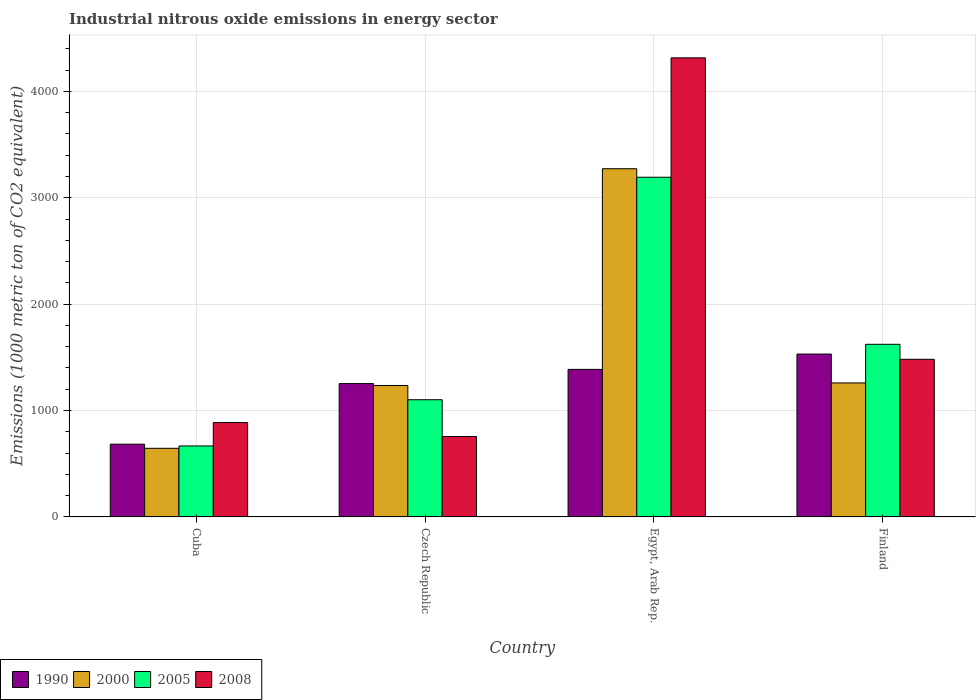How many different coloured bars are there?
Offer a very short reply. 4. Are the number of bars per tick equal to the number of legend labels?
Keep it short and to the point. Yes. Are the number of bars on each tick of the X-axis equal?
Keep it short and to the point. Yes. How many bars are there on the 2nd tick from the right?
Offer a very short reply. 4. What is the label of the 4th group of bars from the left?
Provide a succinct answer. Finland. What is the amount of industrial nitrous oxide emitted in 1990 in Cuba?
Make the answer very short. 683.6. Across all countries, what is the maximum amount of industrial nitrous oxide emitted in 2000?
Your response must be concise. 3272.7. Across all countries, what is the minimum amount of industrial nitrous oxide emitted in 1990?
Your answer should be compact. 683.6. In which country was the amount of industrial nitrous oxide emitted in 2008 maximum?
Keep it short and to the point. Egypt, Arab Rep. In which country was the amount of industrial nitrous oxide emitted in 2008 minimum?
Offer a very short reply. Czech Republic. What is the total amount of industrial nitrous oxide emitted in 2005 in the graph?
Your response must be concise. 6583.6. What is the difference between the amount of industrial nitrous oxide emitted in 2005 in Cuba and that in Egypt, Arab Rep.?
Your answer should be very brief. -2525.5. What is the difference between the amount of industrial nitrous oxide emitted in 2000 in Egypt, Arab Rep. and the amount of industrial nitrous oxide emitted in 2008 in Finland?
Make the answer very short. 1791.2. What is the average amount of industrial nitrous oxide emitted in 1990 per country?
Give a very brief answer. 1213.6. What is the difference between the amount of industrial nitrous oxide emitted of/in 2000 and amount of industrial nitrous oxide emitted of/in 2008 in Egypt, Arab Rep.?
Provide a succinct answer. -1042.3. What is the ratio of the amount of industrial nitrous oxide emitted in 2000 in Cuba to that in Finland?
Provide a short and direct response. 0.51. Is the amount of industrial nitrous oxide emitted in 1990 in Cuba less than that in Finland?
Your answer should be compact. Yes. What is the difference between the highest and the second highest amount of industrial nitrous oxide emitted in 2008?
Offer a very short reply. -2833.5. What is the difference between the highest and the lowest amount of industrial nitrous oxide emitted in 1990?
Offer a terse response. 847.3. In how many countries, is the amount of industrial nitrous oxide emitted in 2008 greater than the average amount of industrial nitrous oxide emitted in 2008 taken over all countries?
Offer a terse response. 1. Is the sum of the amount of industrial nitrous oxide emitted in 2008 in Czech Republic and Finland greater than the maximum amount of industrial nitrous oxide emitted in 1990 across all countries?
Provide a succinct answer. Yes. What does the 4th bar from the right in Finland represents?
Provide a short and direct response. 1990. Is it the case that in every country, the sum of the amount of industrial nitrous oxide emitted in 1990 and amount of industrial nitrous oxide emitted in 2000 is greater than the amount of industrial nitrous oxide emitted in 2008?
Ensure brevity in your answer.  Yes. What is the difference between two consecutive major ticks on the Y-axis?
Your answer should be very brief. 1000. Where does the legend appear in the graph?
Your response must be concise. Bottom left. How many legend labels are there?
Provide a short and direct response. 4. What is the title of the graph?
Ensure brevity in your answer.  Industrial nitrous oxide emissions in energy sector. What is the label or title of the X-axis?
Make the answer very short. Country. What is the label or title of the Y-axis?
Ensure brevity in your answer.  Emissions (1000 metric ton of CO2 equivalent). What is the Emissions (1000 metric ton of CO2 equivalent) of 1990 in Cuba?
Make the answer very short. 683.6. What is the Emissions (1000 metric ton of CO2 equivalent) of 2000 in Cuba?
Provide a succinct answer. 645. What is the Emissions (1000 metric ton of CO2 equivalent) of 2005 in Cuba?
Make the answer very short. 667.1. What is the Emissions (1000 metric ton of CO2 equivalent) of 2008 in Cuba?
Your response must be concise. 886.9. What is the Emissions (1000 metric ton of CO2 equivalent) in 1990 in Czech Republic?
Offer a very short reply. 1253.3. What is the Emissions (1000 metric ton of CO2 equivalent) in 2000 in Czech Republic?
Keep it short and to the point. 1235.4. What is the Emissions (1000 metric ton of CO2 equivalent) in 2005 in Czech Republic?
Ensure brevity in your answer.  1101.5. What is the Emissions (1000 metric ton of CO2 equivalent) of 2008 in Czech Republic?
Give a very brief answer. 756. What is the Emissions (1000 metric ton of CO2 equivalent) in 1990 in Egypt, Arab Rep.?
Offer a terse response. 1386.6. What is the Emissions (1000 metric ton of CO2 equivalent) in 2000 in Egypt, Arab Rep.?
Offer a very short reply. 3272.7. What is the Emissions (1000 metric ton of CO2 equivalent) in 2005 in Egypt, Arab Rep.?
Keep it short and to the point. 3192.6. What is the Emissions (1000 metric ton of CO2 equivalent) of 2008 in Egypt, Arab Rep.?
Ensure brevity in your answer.  4315. What is the Emissions (1000 metric ton of CO2 equivalent) of 1990 in Finland?
Your answer should be very brief. 1530.9. What is the Emissions (1000 metric ton of CO2 equivalent) of 2000 in Finland?
Provide a short and direct response. 1259.4. What is the Emissions (1000 metric ton of CO2 equivalent) of 2005 in Finland?
Provide a succinct answer. 1622.4. What is the Emissions (1000 metric ton of CO2 equivalent) in 2008 in Finland?
Provide a succinct answer. 1481.5. Across all countries, what is the maximum Emissions (1000 metric ton of CO2 equivalent) of 1990?
Your answer should be very brief. 1530.9. Across all countries, what is the maximum Emissions (1000 metric ton of CO2 equivalent) in 2000?
Give a very brief answer. 3272.7. Across all countries, what is the maximum Emissions (1000 metric ton of CO2 equivalent) in 2005?
Your answer should be very brief. 3192.6. Across all countries, what is the maximum Emissions (1000 metric ton of CO2 equivalent) in 2008?
Give a very brief answer. 4315. Across all countries, what is the minimum Emissions (1000 metric ton of CO2 equivalent) in 1990?
Provide a succinct answer. 683.6. Across all countries, what is the minimum Emissions (1000 metric ton of CO2 equivalent) in 2000?
Your answer should be very brief. 645. Across all countries, what is the minimum Emissions (1000 metric ton of CO2 equivalent) in 2005?
Your response must be concise. 667.1. Across all countries, what is the minimum Emissions (1000 metric ton of CO2 equivalent) of 2008?
Offer a terse response. 756. What is the total Emissions (1000 metric ton of CO2 equivalent) of 1990 in the graph?
Offer a very short reply. 4854.4. What is the total Emissions (1000 metric ton of CO2 equivalent) of 2000 in the graph?
Provide a succinct answer. 6412.5. What is the total Emissions (1000 metric ton of CO2 equivalent) in 2005 in the graph?
Give a very brief answer. 6583.6. What is the total Emissions (1000 metric ton of CO2 equivalent) of 2008 in the graph?
Your response must be concise. 7439.4. What is the difference between the Emissions (1000 metric ton of CO2 equivalent) of 1990 in Cuba and that in Czech Republic?
Give a very brief answer. -569.7. What is the difference between the Emissions (1000 metric ton of CO2 equivalent) of 2000 in Cuba and that in Czech Republic?
Ensure brevity in your answer.  -590.4. What is the difference between the Emissions (1000 metric ton of CO2 equivalent) in 2005 in Cuba and that in Czech Republic?
Your answer should be compact. -434.4. What is the difference between the Emissions (1000 metric ton of CO2 equivalent) of 2008 in Cuba and that in Czech Republic?
Give a very brief answer. 130.9. What is the difference between the Emissions (1000 metric ton of CO2 equivalent) of 1990 in Cuba and that in Egypt, Arab Rep.?
Make the answer very short. -703. What is the difference between the Emissions (1000 metric ton of CO2 equivalent) of 2000 in Cuba and that in Egypt, Arab Rep.?
Your response must be concise. -2627.7. What is the difference between the Emissions (1000 metric ton of CO2 equivalent) in 2005 in Cuba and that in Egypt, Arab Rep.?
Make the answer very short. -2525.5. What is the difference between the Emissions (1000 metric ton of CO2 equivalent) in 2008 in Cuba and that in Egypt, Arab Rep.?
Make the answer very short. -3428.1. What is the difference between the Emissions (1000 metric ton of CO2 equivalent) of 1990 in Cuba and that in Finland?
Ensure brevity in your answer.  -847.3. What is the difference between the Emissions (1000 metric ton of CO2 equivalent) of 2000 in Cuba and that in Finland?
Ensure brevity in your answer.  -614.4. What is the difference between the Emissions (1000 metric ton of CO2 equivalent) in 2005 in Cuba and that in Finland?
Make the answer very short. -955.3. What is the difference between the Emissions (1000 metric ton of CO2 equivalent) in 2008 in Cuba and that in Finland?
Your answer should be compact. -594.6. What is the difference between the Emissions (1000 metric ton of CO2 equivalent) of 1990 in Czech Republic and that in Egypt, Arab Rep.?
Offer a terse response. -133.3. What is the difference between the Emissions (1000 metric ton of CO2 equivalent) of 2000 in Czech Republic and that in Egypt, Arab Rep.?
Offer a terse response. -2037.3. What is the difference between the Emissions (1000 metric ton of CO2 equivalent) in 2005 in Czech Republic and that in Egypt, Arab Rep.?
Your answer should be compact. -2091.1. What is the difference between the Emissions (1000 metric ton of CO2 equivalent) of 2008 in Czech Republic and that in Egypt, Arab Rep.?
Offer a terse response. -3559. What is the difference between the Emissions (1000 metric ton of CO2 equivalent) of 1990 in Czech Republic and that in Finland?
Offer a very short reply. -277.6. What is the difference between the Emissions (1000 metric ton of CO2 equivalent) of 2005 in Czech Republic and that in Finland?
Ensure brevity in your answer.  -520.9. What is the difference between the Emissions (1000 metric ton of CO2 equivalent) in 2008 in Czech Republic and that in Finland?
Make the answer very short. -725.5. What is the difference between the Emissions (1000 metric ton of CO2 equivalent) in 1990 in Egypt, Arab Rep. and that in Finland?
Give a very brief answer. -144.3. What is the difference between the Emissions (1000 metric ton of CO2 equivalent) in 2000 in Egypt, Arab Rep. and that in Finland?
Ensure brevity in your answer.  2013.3. What is the difference between the Emissions (1000 metric ton of CO2 equivalent) in 2005 in Egypt, Arab Rep. and that in Finland?
Offer a terse response. 1570.2. What is the difference between the Emissions (1000 metric ton of CO2 equivalent) in 2008 in Egypt, Arab Rep. and that in Finland?
Make the answer very short. 2833.5. What is the difference between the Emissions (1000 metric ton of CO2 equivalent) in 1990 in Cuba and the Emissions (1000 metric ton of CO2 equivalent) in 2000 in Czech Republic?
Keep it short and to the point. -551.8. What is the difference between the Emissions (1000 metric ton of CO2 equivalent) of 1990 in Cuba and the Emissions (1000 metric ton of CO2 equivalent) of 2005 in Czech Republic?
Offer a terse response. -417.9. What is the difference between the Emissions (1000 metric ton of CO2 equivalent) in 1990 in Cuba and the Emissions (1000 metric ton of CO2 equivalent) in 2008 in Czech Republic?
Offer a very short reply. -72.4. What is the difference between the Emissions (1000 metric ton of CO2 equivalent) in 2000 in Cuba and the Emissions (1000 metric ton of CO2 equivalent) in 2005 in Czech Republic?
Your response must be concise. -456.5. What is the difference between the Emissions (1000 metric ton of CO2 equivalent) of 2000 in Cuba and the Emissions (1000 metric ton of CO2 equivalent) of 2008 in Czech Republic?
Make the answer very short. -111. What is the difference between the Emissions (1000 metric ton of CO2 equivalent) in 2005 in Cuba and the Emissions (1000 metric ton of CO2 equivalent) in 2008 in Czech Republic?
Give a very brief answer. -88.9. What is the difference between the Emissions (1000 metric ton of CO2 equivalent) in 1990 in Cuba and the Emissions (1000 metric ton of CO2 equivalent) in 2000 in Egypt, Arab Rep.?
Provide a succinct answer. -2589.1. What is the difference between the Emissions (1000 metric ton of CO2 equivalent) of 1990 in Cuba and the Emissions (1000 metric ton of CO2 equivalent) of 2005 in Egypt, Arab Rep.?
Offer a terse response. -2509. What is the difference between the Emissions (1000 metric ton of CO2 equivalent) in 1990 in Cuba and the Emissions (1000 metric ton of CO2 equivalent) in 2008 in Egypt, Arab Rep.?
Provide a succinct answer. -3631.4. What is the difference between the Emissions (1000 metric ton of CO2 equivalent) of 2000 in Cuba and the Emissions (1000 metric ton of CO2 equivalent) of 2005 in Egypt, Arab Rep.?
Keep it short and to the point. -2547.6. What is the difference between the Emissions (1000 metric ton of CO2 equivalent) of 2000 in Cuba and the Emissions (1000 metric ton of CO2 equivalent) of 2008 in Egypt, Arab Rep.?
Offer a terse response. -3670. What is the difference between the Emissions (1000 metric ton of CO2 equivalent) of 2005 in Cuba and the Emissions (1000 metric ton of CO2 equivalent) of 2008 in Egypt, Arab Rep.?
Offer a very short reply. -3647.9. What is the difference between the Emissions (1000 metric ton of CO2 equivalent) of 1990 in Cuba and the Emissions (1000 metric ton of CO2 equivalent) of 2000 in Finland?
Provide a short and direct response. -575.8. What is the difference between the Emissions (1000 metric ton of CO2 equivalent) of 1990 in Cuba and the Emissions (1000 metric ton of CO2 equivalent) of 2005 in Finland?
Offer a terse response. -938.8. What is the difference between the Emissions (1000 metric ton of CO2 equivalent) in 1990 in Cuba and the Emissions (1000 metric ton of CO2 equivalent) in 2008 in Finland?
Your answer should be very brief. -797.9. What is the difference between the Emissions (1000 metric ton of CO2 equivalent) in 2000 in Cuba and the Emissions (1000 metric ton of CO2 equivalent) in 2005 in Finland?
Your answer should be very brief. -977.4. What is the difference between the Emissions (1000 metric ton of CO2 equivalent) of 2000 in Cuba and the Emissions (1000 metric ton of CO2 equivalent) of 2008 in Finland?
Provide a succinct answer. -836.5. What is the difference between the Emissions (1000 metric ton of CO2 equivalent) in 2005 in Cuba and the Emissions (1000 metric ton of CO2 equivalent) in 2008 in Finland?
Your answer should be compact. -814.4. What is the difference between the Emissions (1000 metric ton of CO2 equivalent) in 1990 in Czech Republic and the Emissions (1000 metric ton of CO2 equivalent) in 2000 in Egypt, Arab Rep.?
Give a very brief answer. -2019.4. What is the difference between the Emissions (1000 metric ton of CO2 equivalent) in 1990 in Czech Republic and the Emissions (1000 metric ton of CO2 equivalent) in 2005 in Egypt, Arab Rep.?
Provide a short and direct response. -1939.3. What is the difference between the Emissions (1000 metric ton of CO2 equivalent) of 1990 in Czech Republic and the Emissions (1000 metric ton of CO2 equivalent) of 2008 in Egypt, Arab Rep.?
Offer a very short reply. -3061.7. What is the difference between the Emissions (1000 metric ton of CO2 equivalent) of 2000 in Czech Republic and the Emissions (1000 metric ton of CO2 equivalent) of 2005 in Egypt, Arab Rep.?
Offer a terse response. -1957.2. What is the difference between the Emissions (1000 metric ton of CO2 equivalent) of 2000 in Czech Republic and the Emissions (1000 metric ton of CO2 equivalent) of 2008 in Egypt, Arab Rep.?
Give a very brief answer. -3079.6. What is the difference between the Emissions (1000 metric ton of CO2 equivalent) of 2005 in Czech Republic and the Emissions (1000 metric ton of CO2 equivalent) of 2008 in Egypt, Arab Rep.?
Offer a very short reply. -3213.5. What is the difference between the Emissions (1000 metric ton of CO2 equivalent) of 1990 in Czech Republic and the Emissions (1000 metric ton of CO2 equivalent) of 2005 in Finland?
Your answer should be compact. -369.1. What is the difference between the Emissions (1000 metric ton of CO2 equivalent) of 1990 in Czech Republic and the Emissions (1000 metric ton of CO2 equivalent) of 2008 in Finland?
Offer a very short reply. -228.2. What is the difference between the Emissions (1000 metric ton of CO2 equivalent) in 2000 in Czech Republic and the Emissions (1000 metric ton of CO2 equivalent) in 2005 in Finland?
Keep it short and to the point. -387. What is the difference between the Emissions (1000 metric ton of CO2 equivalent) of 2000 in Czech Republic and the Emissions (1000 metric ton of CO2 equivalent) of 2008 in Finland?
Make the answer very short. -246.1. What is the difference between the Emissions (1000 metric ton of CO2 equivalent) in 2005 in Czech Republic and the Emissions (1000 metric ton of CO2 equivalent) in 2008 in Finland?
Give a very brief answer. -380. What is the difference between the Emissions (1000 metric ton of CO2 equivalent) in 1990 in Egypt, Arab Rep. and the Emissions (1000 metric ton of CO2 equivalent) in 2000 in Finland?
Provide a short and direct response. 127.2. What is the difference between the Emissions (1000 metric ton of CO2 equivalent) of 1990 in Egypt, Arab Rep. and the Emissions (1000 metric ton of CO2 equivalent) of 2005 in Finland?
Your answer should be very brief. -235.8. What is the difference between the Emissions (1000 metric ton of CO2 equivalent) in 1990 in Egypt, Arab Rep. and the Emissions (1000 metric ton of CO2 equivalent) in 2008 in Finland?
Offer a terse response. -94.9. What is the difference between the Emissions (1000 metric ton of CO2 equivalent) of 2000 in Egypt, Arab Rep. and the Emissions (1000 metric ton of CO2 equivalent) of 2005 in Finland?
Give a very brief answer. 1650.3. What is the difference between the Emissions (1000 metric ton of CO2 equivalent) of 2000 in Egypt, Arab Rep. and the Emissions (1000 metric ton of CO2 equivalent) of 2008 in Finland?
Keep it short and to the point. 1791.2. What is the difference between the Emissions (1000 metric ton of CO2 equivalent) of 2005 in Egypt, Arab Rep. and the Emissions (1000 metric ton of CO2 equivalent) of 2008 in Finland?
Keep it short and to the point. 1711.1. What is the average Emissions (1000 metric ton of CO2 equivalent) of 1990 per country?
Keep it short and to the point. 1213.6. What is the average Emissions (1000 metric ton of CO2 equivalent) of 2000 per country?
Offer a terse response. 1603.12. What is the average Emissions (1000 metric ton of CO2 equivalent) of 2005 per country?
Provide a short and direct response. 1645.9. What is the average Emissions (1000 metric ton of CO2 equivalent) of 2008 per country?
Keep it short and to the point. 1859.85. What is the difference between the Emissions (1000 metric ton of CO2 equivalent) in 1990 and Emissions (1000 metric ton of CO2 equivalent) in 2000 in Cuba?
Provide a short and direct response. 38.6. What is the difference between the Emissions (1000 metric ton of CO2 equivalent) of 1990 and Emissions (1000 metric ton of CO2 equivalent) of 2005 in Cuba?
Provide a succinct answer. 16.5. What is the difference between the Emissions (1000 metric ton of CO2 equivalent) in 1990 and Emissions (1000 metric ton of CO2 equivalent) in 2008 in Cuba?
Your response must be concise. -203.3. What is the difference between the Emissions (1000 metric ton of CO2 equivalent) in 2000 and Emissions (1000 metric ton of CO2 equivalent) in 2005 in Cuba?
Your answer should be compact. -22.1. What is the difference between the Emissions (1000 metric ton of CO2 equivalent) in 2000 and Emissions (1000 metric ton of CO2 equivalent) in 2008 in Cuba?
Offer a terse response. -241.9. What is the difference between the Emissions (1000 metric ton of CO2 equivalent) in 2005 and Emissions (1000 metric ton of CO2 equivalent) in 2008 in Cuba?
Your response must be concise. -219.8. What is the difference between the Emissions (1000 metric ton of CO2 equivalent) in 1990 and Emissions (1000 metric ton of CO2 equivalent) in 2005 in Czech Republic?
Your answer should be compact. 151.8. What is the difference between the Emissions (1000 metric ton of CO2 equivalent) of 1990 and Emissions (1000 metric ton of CO2 equivalent) of 2008 in Czech Republic?
Your response must be concise. 497.3. What is the difference between the Emissions (1000 metric ton of CO2 equivalent) of 2000 and Emissions (1000 metric ton of CO2 equivalent) of 2005 in Czech Republic?
Provide a succinct answer. 133.9. What is the difference between the Emissions (1000 metric ton of CO2 equivalent) of 2000 and Emissions (1000 metric ton of CO2 equivalent) of 2008 in Czech Republic?
Your response must be concise. 479.4. What is the difference between the Emissions (1000 metric ton of CO2 equivalent) of 2005 and Emissions (1000 metric ton of CO2 equivalent) of 2008 in Czech Republic?
Give a very brief answer. 345.5. What is the difference between the Emissions (1000 metric ton of CO2 equivalent) of 1990 and Emissions (1000 metric ton of CO2 equivalent) of 2000 in Egypt, Arab Rep.?
Offer a very short reply. -1886.1. What is the difference between the Emissions (1000 metric ton of CO2 equivalent) of 1990 and Emissions (1000 metric ton of CO2 equivalent) of 2005 in Egypt, Arab Rep.?
Offer a very short reply. -1806. What is the difference between the Emissions (1000 metric ton of CO2 equivalent) of 1990 and Emissions (1000 metric ton of CO2 equivalent) of 2008 in Egypt, Arab Rep.?
Keep it short and to the point. -2928.4. What is the difference between the Emissions (1000 metric ton of CO2 equivalent) of 2000 and Emissions (1000 metric ton of CO2 equivalent) of 2005 in Egypt, Arab Rep.?
Make the answer very short. 80.1. What is the difference between the Emissions (1000 metric ton of CO2 equivalent) in 2000 and Emissions (1000 metric ton of CO2 equivalent) in 2008 in Egypt, Arab Rep.?
Ensure brevity in your answer.  -1042.3. What is the difference between the Emissions (1000 metric ton of CO2 equivalent) in 2005 and Emissions (1000 metric ton of CO2 equivalent) in 2008 in Egypt, Arab Rep.?
Keep it short and to the point. -1122.4. What is the difference between the Emissions (1000 metric ton of CO2 equivalent) of 1990 and Emissions (1000 metric ton of CO2 equivalent) of 2000 in Finland?
Give a very brief answer. 271.5. What is the difference between the Emissions (1000 metric ton of CO2 equivalent) of 1990 and Emissions (1000 metric ton of CO2 equivalent) of 2005 in Finland?
Your response must be concise. -91.5. What is the difference between the Emissions (1000 metric ton of CO2 equivalent) of 1990 and Emissions (1000 metric ton of CO2 equivalent) of 2008 in Finland?
Offer a terse response. 49.4. What is the difference between the Emissions (1000 metric ton of CO2 equivalent) of 2000 and Emissions (1000 metric ton of CO2 equivalent) of 2005 in Finland?
Ensure brevity in your answer.  -363. What is the difference between the Emissions (1000 metric ton of CO2 equivalent) of 2000 and Emissions (1000 metric ton of CO2 equivalent) of 2008 in Finland?
Give a very brief answer. -222.1. What is the difference between the Emissions (1000 metric ton of CO2 equivalent) of 2005 and Emissions (1000 metric ton of CO2 equivalent) of 2008 in Finland?
Make the answer very short. 140.9. What is the ratio of the Emissions (1000 metric ton of CO2 equivalent) in 1990 in Cuba to that in Czech Republic?
Your answer should be compact. 0.55. What is the ratio of the Emissions (1000 metric ton of CO2 equivalent) in 2000 in Cuba to that in Czech Republic?
Ensure brevity in your answer.  0.52. What is the ratio of the Emissions (1000 metric ton of CO2 equivalent) of 2005 in Cuba to that in Czech Republic?
Offer a terse response. 0.61. What is the ratio of the Emissions (1000 metric ton of CO2 equivalent) of 2008 in Cuba to that in Czech Republic?
Keep it short and to the point. 1.17. What is the ratio of the Emissions (1000 metric ton of CO2 equivalent) of 1990 in Cuba to that in Egypt, Arab Rep.?
Provide a succinct answer. 0.49. What is the ratio of the Emissions (1000 metric ton of CO2 equivalent) of 2000 in Cuba to that in Egypt, Arab Rep.?
Provide a short and direct response. 0.2. What is the ratio of the Emissions (1000 metric ton of CO2 equivalent) in 2005 in Cuba to that in Egypt, Arab Rep.?
Offer a very short reply. 0.21. What is the ratio of the Emissions (1000 metric ton of CO2 equivalent) in 2008 in Cuba to that in Egypt, Arab Rep.?
Ensure brevity in your answer.  0.21. What is the ratio of the Emissions (1000 metric ton of CO2 equivalent) of 1990 in Cuba to that in Finland?
Provide a succinct answer. 0.45. What is the ratio of the Emissions (1000 metric ton of CO2 equivalent) of 2000 in Cuba to that in Finland?
Ensure brevity in your answer.  0.51. What is the ratio of the Emissions (1000 metric ton of CO2 equivalent) in 2005 in Cuba to that in Finland?
Offer a very short reply. 0.41. What is the ratio of the Emissions (1000 metric ton of CO2 equivalent) in 2008 in Cuba to that in Finland?
Your answer should be very brief. 0.6. What is the ratio of the Emissions (1000 metric ton of CO2 equivalent) in 1990 in Czech Republic to that in Egypt, Arab Rep.?
Provide a succinct answer. 0.9. What is the ratio of the Emissions (1000 metric ton of CO2 equivalent) of 2000 in Czech Republic to that in Egypt, Arab Rep.?
Give a very brief answer. 0.38. What is the ratio of the Emissions (1000 metric ton of CO2 equivalent) of 2005 in Czech Republic to that in Egypt, Arab Rep.?
Your answer should be compact. 0.34. What is the ratio of the Emissions (1000 metric ton of CO2 equivalent) of 2008 in Czech Republic to that in Egypt, Arab Rep.?
Offer a very short reply. 0.18. What is the ratio of the Emissions (1000 metric ton of CO2 equivalent) of 1990 in Czech Republic to that in Finland?
Provide a short and direct response. 0.82. What is the ratio of the Emissions (1000 metric ton of CO2 equivalent) in 2000 in Czech Republic to that in Finland?
Offer a very short reply. 0.98. What is the ratio of the Emissions (1000 metric ton of CO2 equivalent) in 2005 in Czech Republic to that in Finland?
Provide a succinct answer. 0.68. What is the ratio of the Emissions (1000 metric ton of CO2 equivalent) in 2008 in Czech Republic to that in Finland?
Provide a succinct answer. 0.51. What is the ratio of the Emissions (1000 metric ton of CO2 equivalent) of 1990 in Egypt, Arab Rep. to that in Finland?
Provide a succinct answer. 0.91. What is the ratio of the Emissions (1000 metric ton of CO2 equivalent) of 2000 in Egypt, Arab Rep. to that in Finland?
Give a very brief answer. 2.6. What is the ratio of the Emissions (1000 metric ton of CO2 equivalent) of 2005 in Egypt, Arab Rep. to that in Finland?
Make the answer very short. 1.97. What is the ratio of the Emissions (1000 metric ton of CO2 equivalent) of 2008 in Egypt, Arab Rep. to that in Finland?
Offer a very short reply. 2.91. What is the difference between the highest and the second highest Emissions (1000 metric ton of CO2 equivalent) in 1990?
Your response must be concise. 144.3. What is the difference between the highest and the second highest Emissions (1000 metric ton of CO2 equivalent) in 2000?
Your response must be concise. 2013.3. What is the difference between the highest and the second highest Emissions (1000 metric ton of CO2 equivalent) of 2005?
Give a very brief answer. 1570.2. What is the difference between the highest and the second highest Emissions (1000 metric ton of CO2 equivalent) in 2008?
Ensure brevity in your answer.  2833.5. What is the difference between the highest and the lowest Emissions (1000 metric ton of CO2 equivalent) in 1990?
Offer a terse response. 847.3. What is the difference between the highest and the lowest Emissions (1000 metric ton of CO2 equivalent) in 2000?
Keep it short and to the point. 2627.7. What is the difference between the highest and the lowest Emissions (1000 metric ton of CO2 equivalent) of 2005?
Provide a succinct answer. 2525.5. What is the difference between the highest and the lowest Emissions (1000 metric ton of CO2 equivalent) of 2008?
Your response must be concise. 3559. 